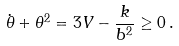<formula> <loc_0><loc_0><loc_500><loc_500>\dot { \theta } + \theta ^ { 2 } = 3 V - \frac { k } { b ^ { 2 } } \geq 0 \, .</formula> 